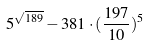Convert formula to latex. <formula><loc_0><loc_0><loc_500><loc_500>5 ^ { \sqrt { 1 8 9 } } - 3 8 1 \cdot ( \frac { 1 9 7 } { 1 0 } ) ^ { 5 }</formula> 